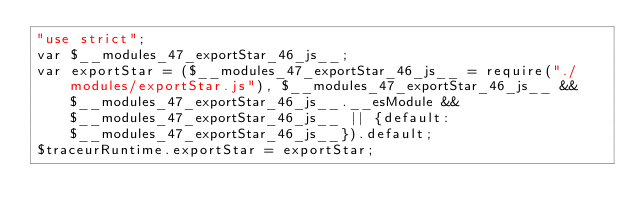Convert code to text. <code><loc_0><loc_0><loc_500><loc_500><_JavaScript_>"use strict";
var $__modules_47_exportStar_46_js__;
var exportStar = ($__modules_47_exportStar_46_js__ = require("./modules/exportStar.js"), $__modules_47_exportStar_46_js__ && $__modules_47_exportStar_46_js__.__esModule && $__modules_47_exportStar_46_js__ || {default: $__modules_47_exportStar_46_js__}).default;
$traceurRuntime.exportStar = exportStar;
</code> 